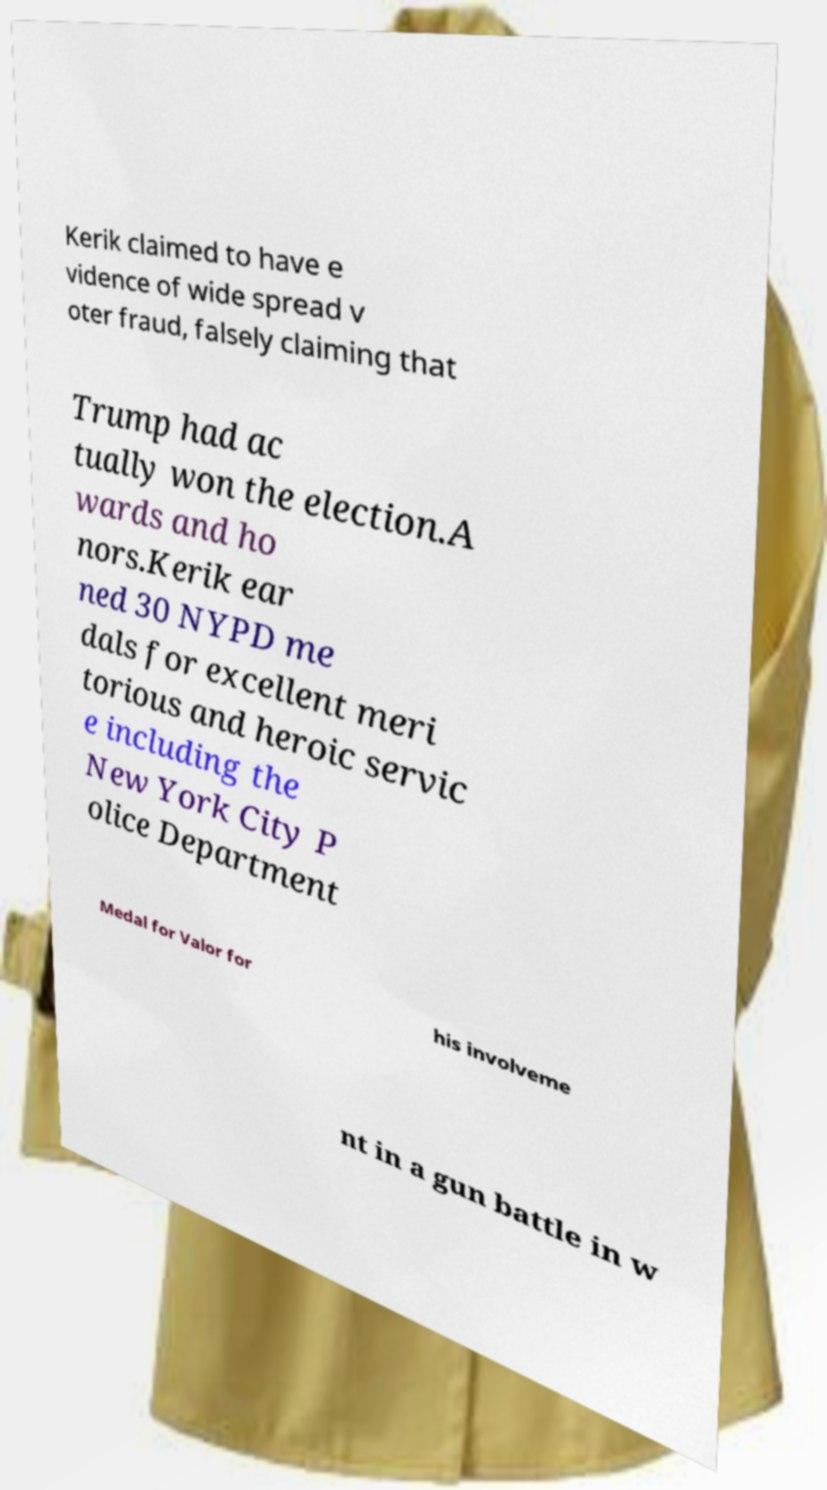Could you extract and type out the text from this image? Kerik claimed to have e vidence of wide spread v oter fraud, falsely claiming that Trump had ac tually won the election.A wards and ho nors.Kerik ear ned 30 NYPD me dals for excellent meri torious and heroic servic e including the New York City P olice Department Medal for Valor for his involveme nt in a gun battle in w 